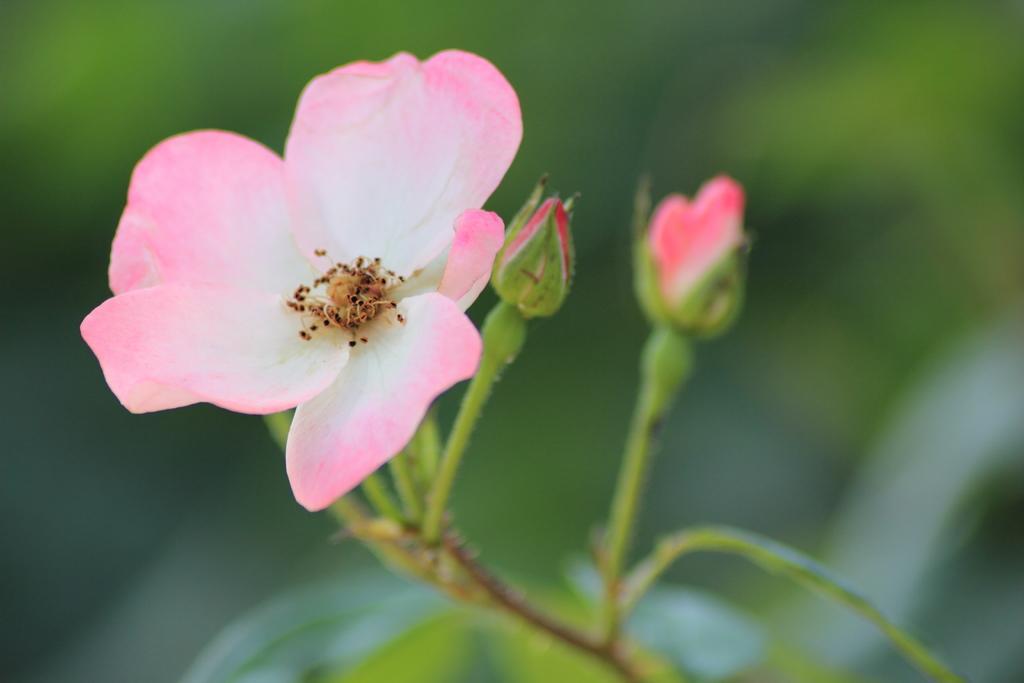Describe this image in one or two sentences. In this image, we can see rose flower and buds along with stem. 